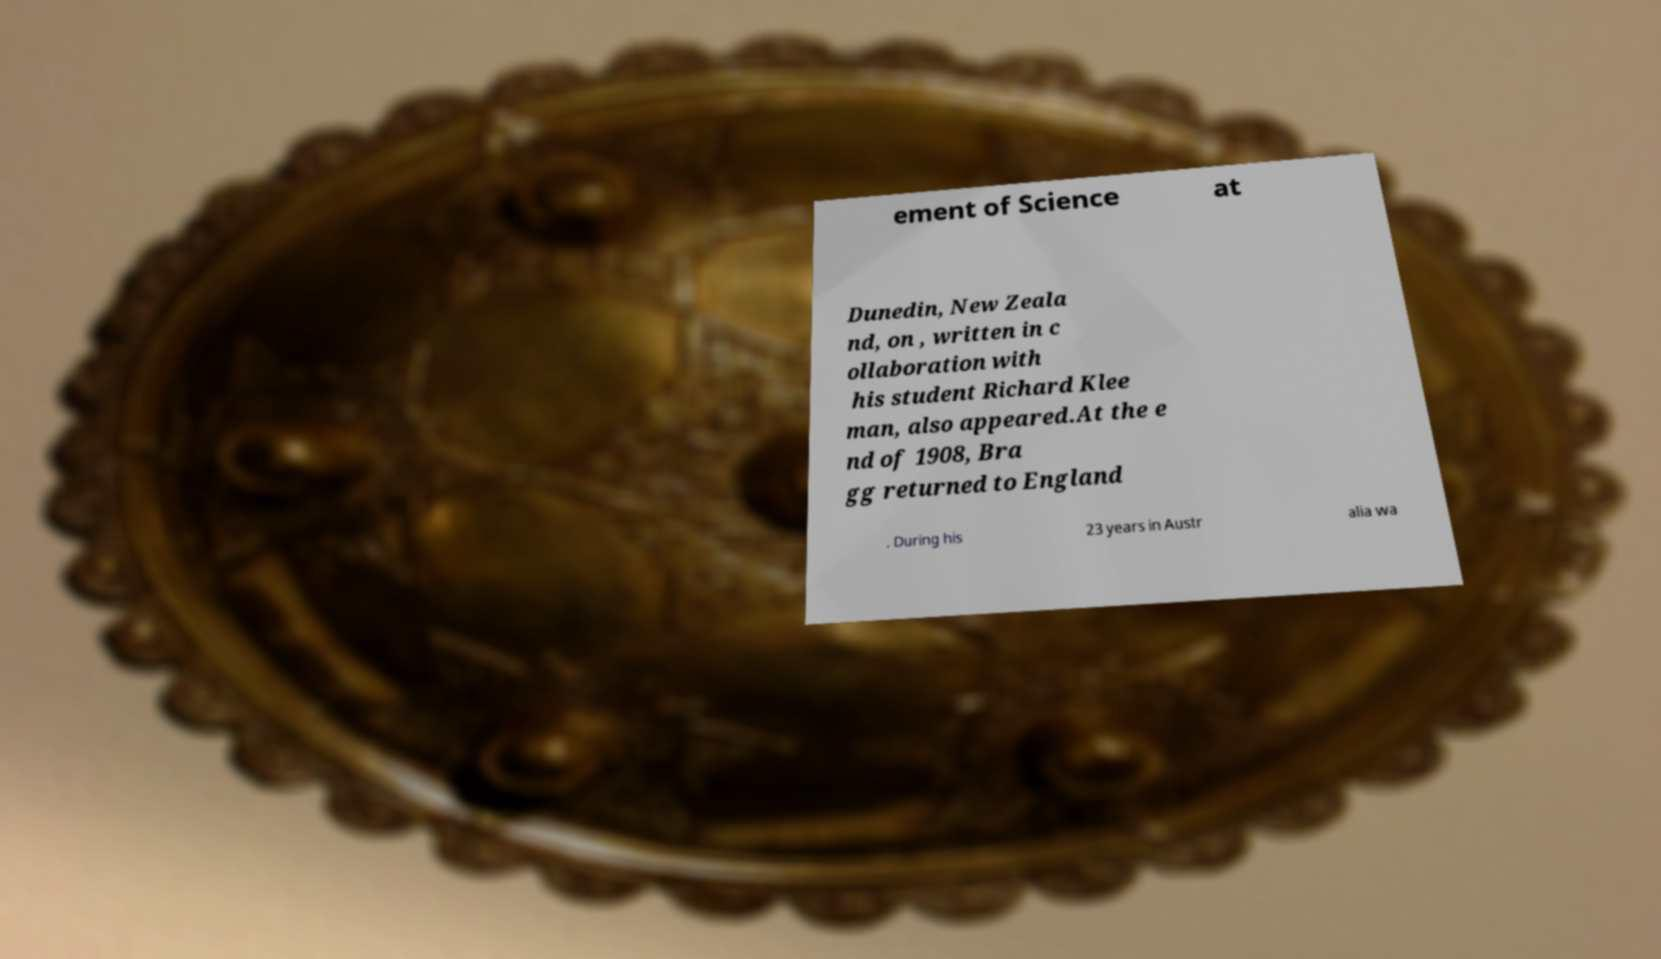Please identify and transcribe the text found in this image. ement of Science at Dunedin, New Zeala nd, on , written in c ollaboration with his student Richard Klee man, also appeared.At the e nd of 1908, Bra gg returned to England . During his 23 years in Austr alia wa 